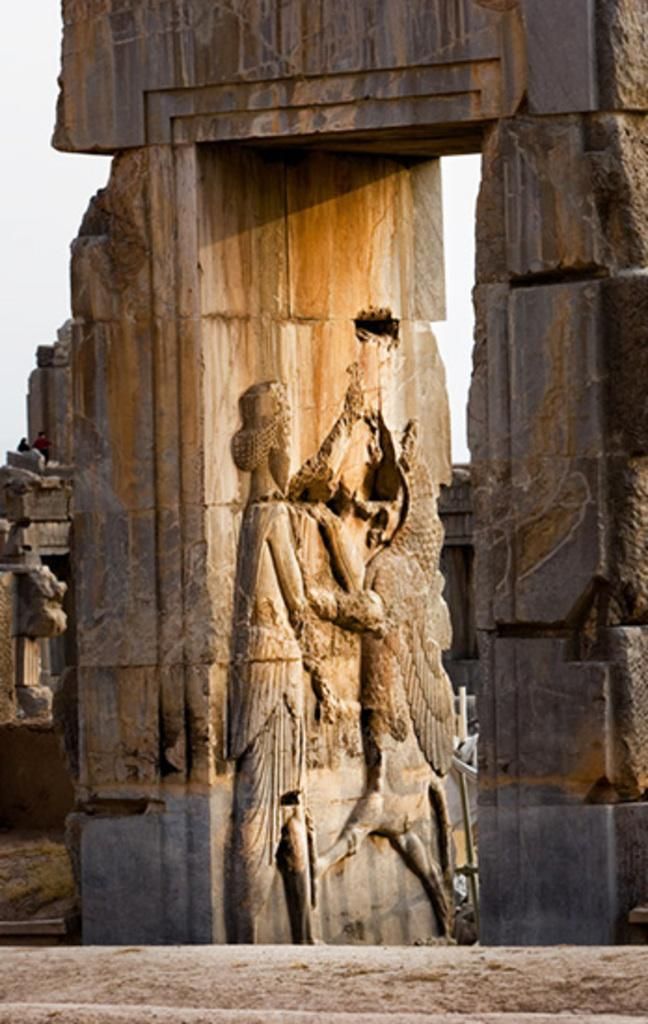What is featured on the wall in the image? There are designs on a wall in the image. Can you describe the people visible in the image? There are people visible in the image, but their specific actions or characteristics are not mentioned in the provided facts. What type of thrill can be experienced by the sun in the image? The image does not depict the sun or any emotions or experiences related to it. Is there a bath visible in the image? There is no mention of a bath in the provided facts about the image. 